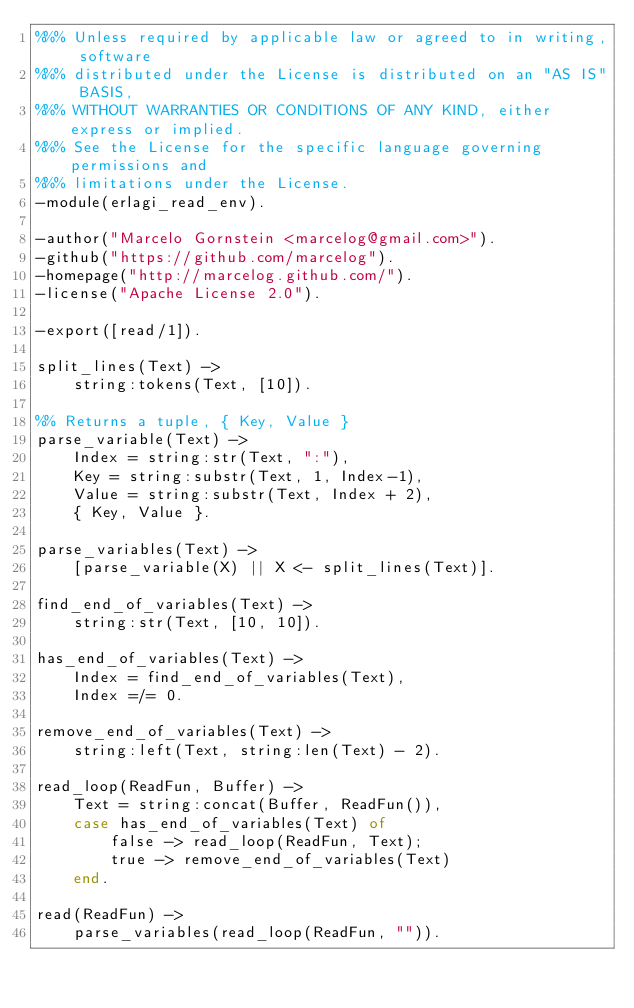<code> <loc_0><loc_0><loc_500><loc_500><_Erlang_>%%% Unless required by applicable law or agreed to in writing, software
%%% distributed under the License is distributed on an "AS IS" BASIS,
%%% WITHOUT WARRANTIES OR CONDITIONS OF ANY KIND, either express or implied.
%%% See the License for the specific language governing permissions and
%%% limitations under the License.
-module(erlagi_read_env).

-author("Marcelo Gornstein <marcelog@gmail.com>").
-github("https://github.com/marcelog").
-homepage("http://marcelog.github.com/").
-license("Apache License 2.0").

-export([read/1]).

split_lines(Text) ->
    string:tokens(Text, [10]).

%% Returns a tuple, { Key, Value }
parse_variable(Text) ->
    Index = string:str(Text, ":"),
    Key = string:substr(Text, 1, Index-1),
    Value = string:substr(Text, Index + 2),
    { Key, Value }.

parse_variables(Text) ->
    [parse_variable(X) || X <- split_lines(Text)].

find_end_of_variables(Text) ->
    string:str(Text, [10, 10]).

has_end_of_variables(Text) ->
    Index = find_end_of_variables(Text),
    Index =/= 0.

remove_end_of_variables(Text) ->
    string:left(Text, string:len(Text) - 2).

read_loop(ReadFun, Buffer) ->
    Text = string:concat(Buffer, ReadFun()),
    case has_end_of_variables(Text) of
        false -> read_loop(ReadFun, Text);
        true -> remove_end_of_variables(Text)
    end.

read(ReadFun) ->
    parse_variables(read_loop(ReadFun, "")).


</code> 